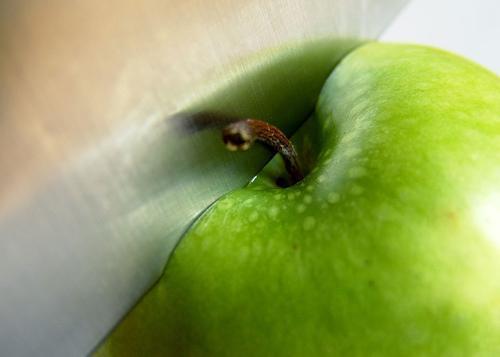Is the given caption "The apple is under the knife." fitting for the image?
Answer yes or no. Yes. 